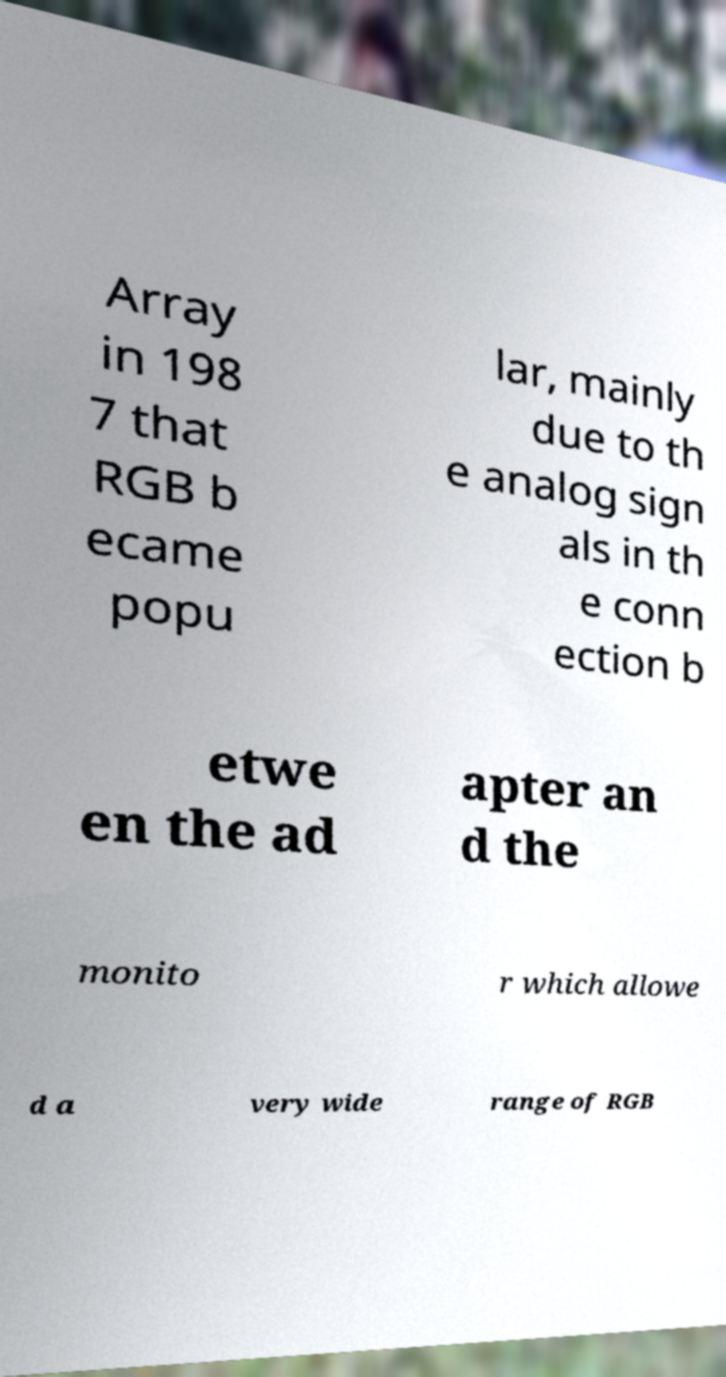I need the written content from this picture converted into text. Can you do that? Array in 198 7 that RGB b ecame popu lar, mainly due to th e analog sign als in th e conn ection b etwe en the ad apter an d the monito r which allowe d a very wide range of RGB 